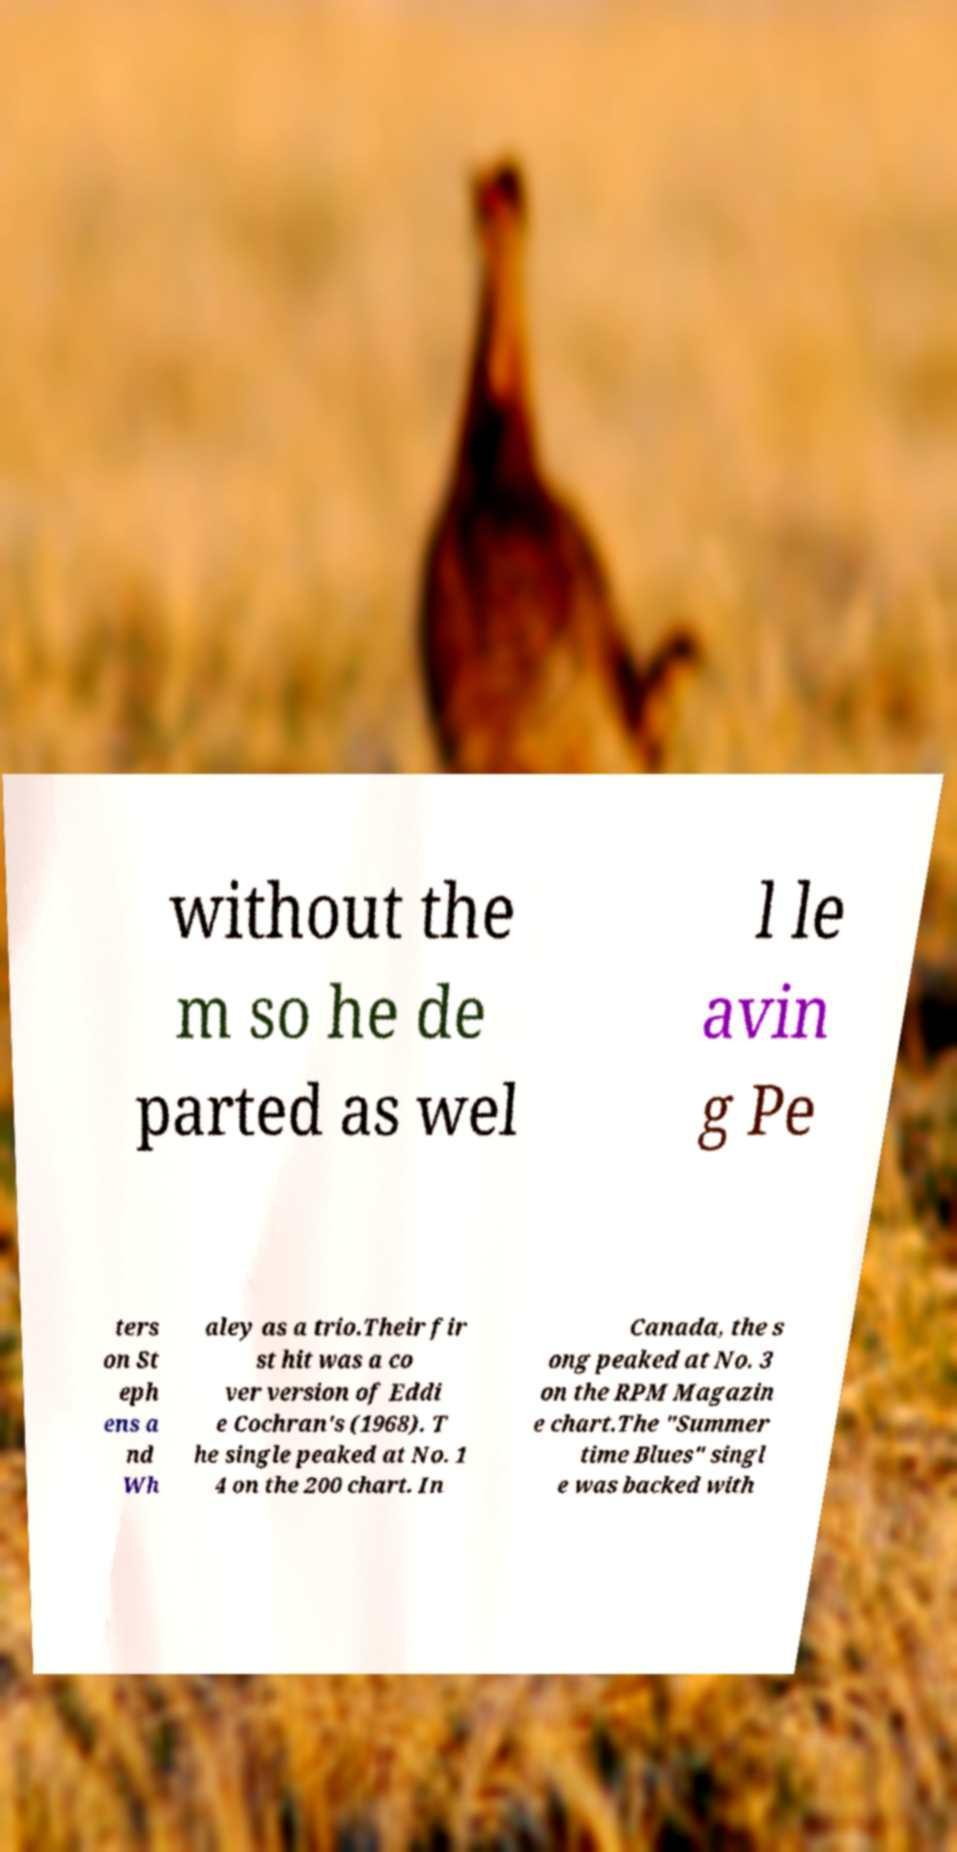Could you extract and type out the text from this image? without the m so he de parted as wel l le avin g Pe ters on St eph ens a nd Wh aley as a trio.Their fir st hit was a co ver version of Eddi e Cochran's (1968). T he single peaked at No. 1 4 on the 200 chart. In Canada, the s ong peaked at No. 3 on the RPM Magazin e chart.The "Summer time Blues" singl e was backed with 